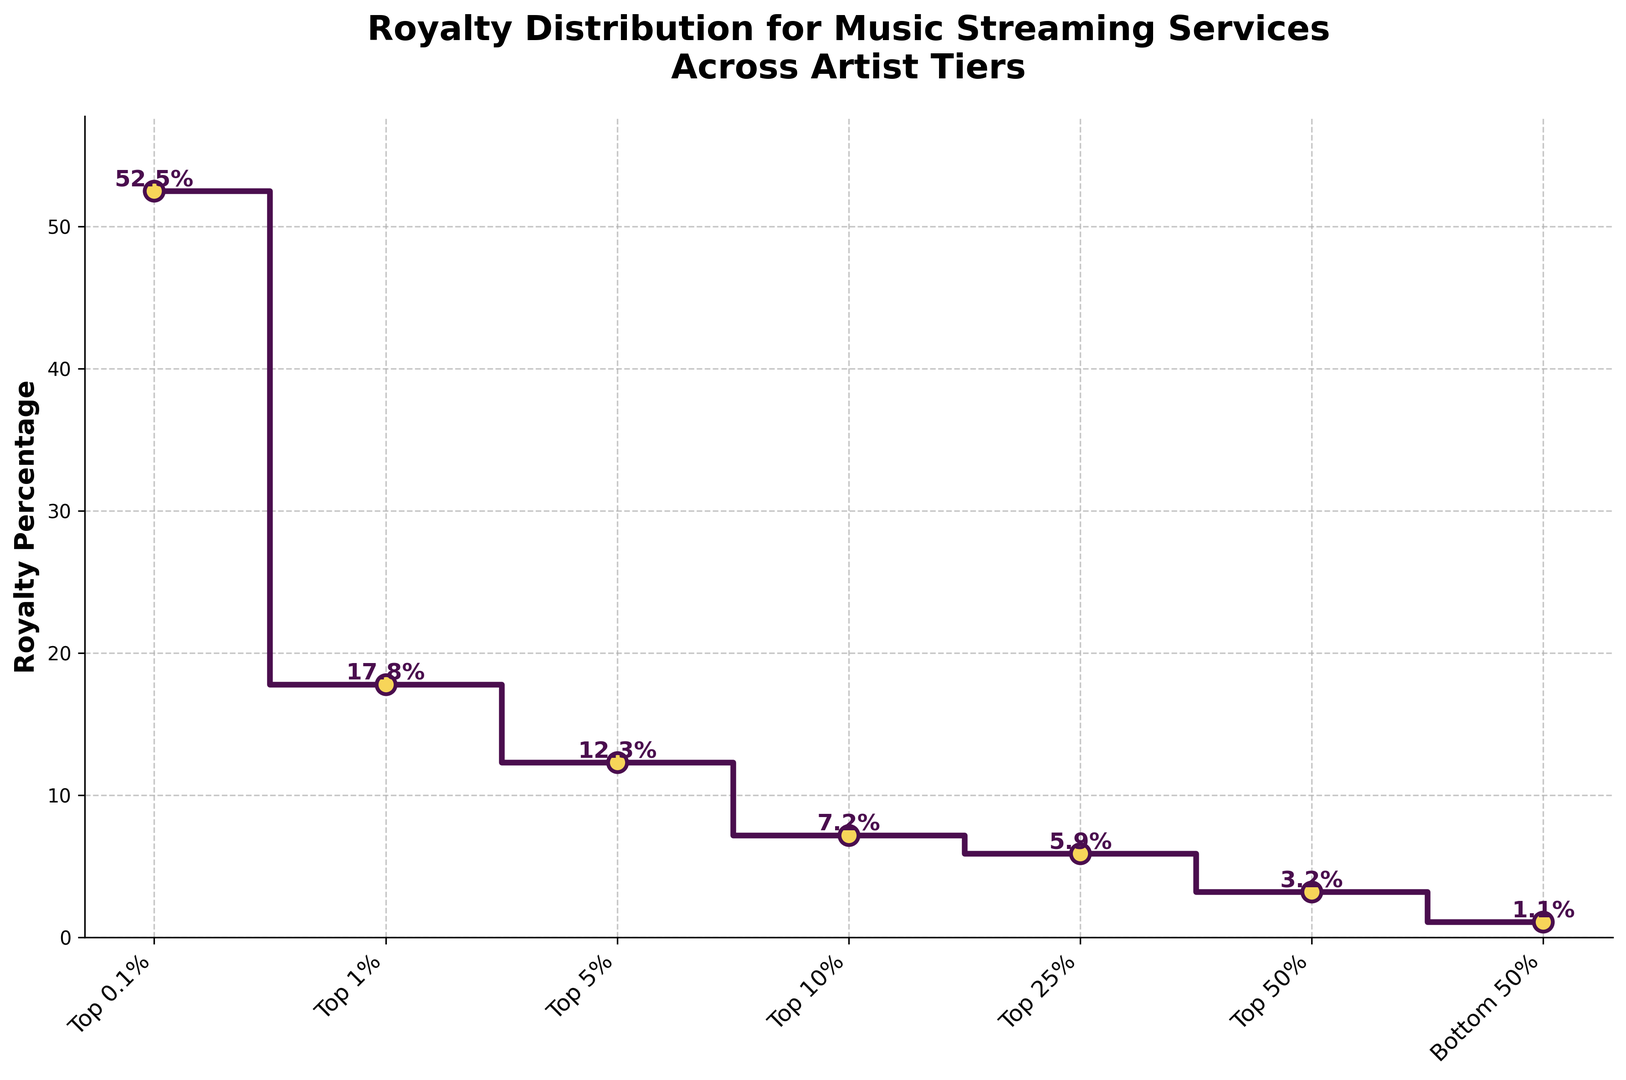What's the royalty percentage for the Top 1% artist tier? Look at the point labeled "Top 1%" on the x-axis and read its corresponding y-axis value. It shows 17.8%.
Answer: 17.8% Which artist tier receives the highest royalty percentage? Find the tallest point (or the point with the highest y-value) on the plot; it corresponds to the "Top 0.1%" with 52.5%.
Answer: Top 0.1% What is the difference in royalty percentage between the Top 0.1% and the Top 5% artist tiers? The royalty percentage for the Top 0.1% is 52.5% and for the Top 5% it is 12.3%. Subtract 12.3% from 52.5% to get the difference: 52.5% - 12.3% = 40.2%.
Answer: 40.2% What is the average royalty percentage of the Top 10%, Top 25%, and Top 50% artist tiers? The royalty percentages are 7.2%, 5.9%, and 3.2%. Add these values and divide by the number of tiers: (7.2% + 5.9% + 3.2%) / 3 = 16.3% / 3 ≈ 5.43%.
Answer: 5.43% Is the royalty percentage for the Bottom 50% artist tier greater or less than the Top 10% artist tier? Compare the two values: Bottom 50% is 1.1% and Top 10% is 7.2%. 1.1% is less than 7.2%.
Answer: Less By how much does the royalty percentage drop from the Top 1% tier to the Top 25% tier? The royalty percentage for the Top 1% is 17.8% and for the Top 25% it is 5.9%. Subtract 5.9% from 17.8% to find the drop: 17.8% - 5.9% = 11.9%.
Answer: 11.9% Which artist tier has a lower royalty percentage, the Top 50% or the Top 25%? Compare the values: 3.2% for Top 50% and 5.9% for Top 25%. 3.2% is lower.
Answer: Top 50% What is the sum of the royalty percentages for the Top 0.1% and the Top 50% artist tiers? The percentages are 52.5% for Top 0.1% and 3.2% for Top 50%. Add these two values: 52.5% + 3.2% = 55.7%.
Answer: 55.7% Which artist tier has a royalty percentage closest to 10%? The artist tiers’ percentages are: Top 10% (7.2%), Top 5% (12.3%), and others. The closest to 10% is 7.2% (Top 10%).
Answer: Top 10% How much more royalty percentage does the Top 1% tier receive compared to the Bottom 50% tier? The Top 1% tier receives 17.8% and the Bottom 50% receives 1.1%. Subtract 1.1% from 17.8% to find the difference: 17.8% - 1.1% = 16.7%.
Answer: 16.7% 